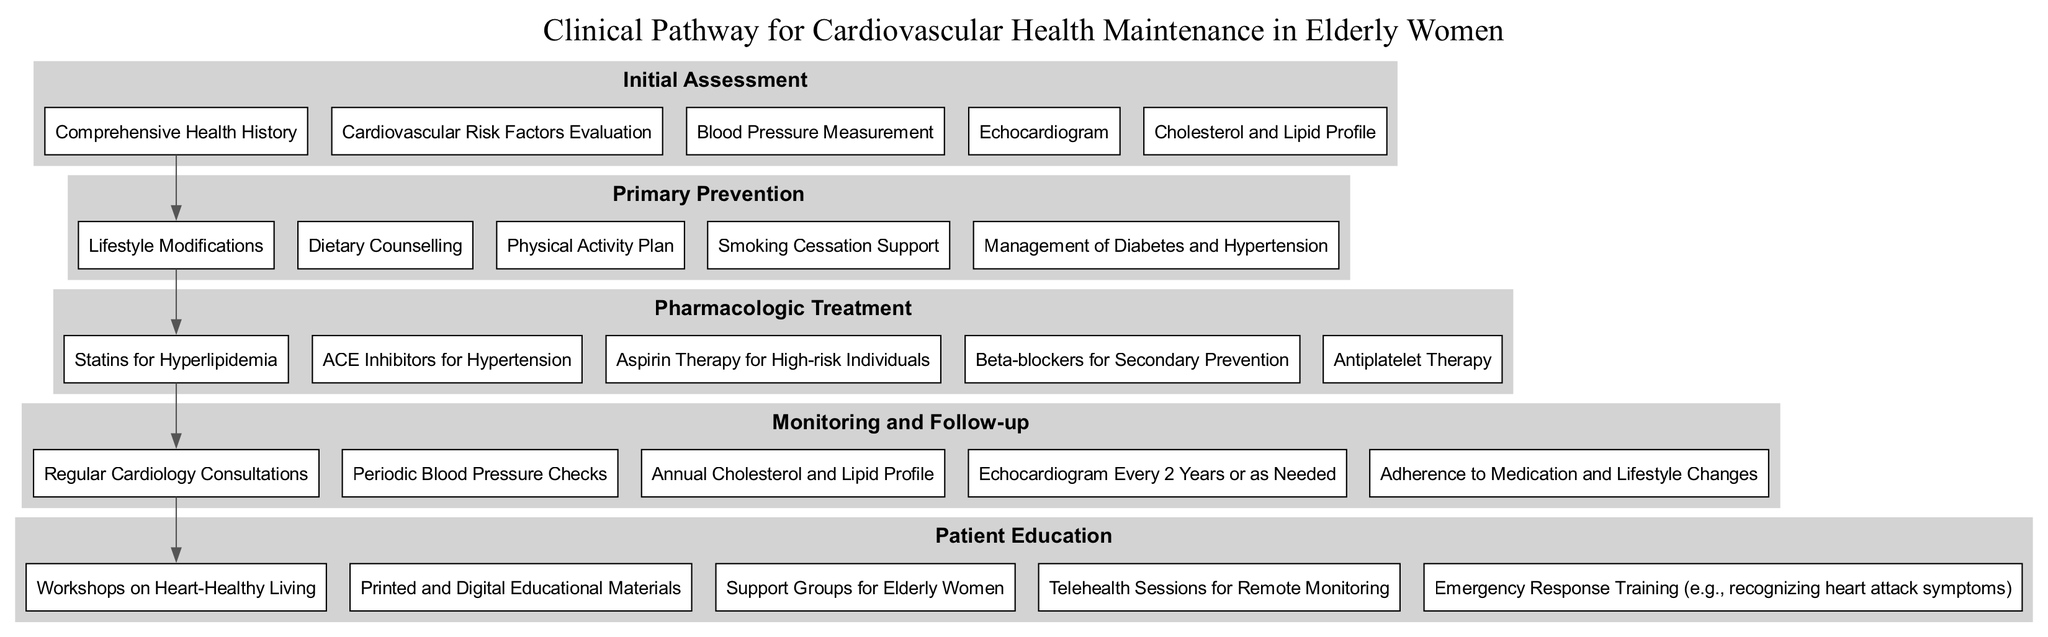What is the first stage in the Clinical Pathway? The first stage listed in the elements of the diagram is "Initial Assessment". It is presented at the top of the pathway, indicating the starting point for cardiovascular health maintenance.
Answer: Initial Assessment How many components are included in the Primary Prevention stage? The diagram indicates that there are five components listed under the Primary Prevention stage, reflecting various strategies to prevent cardiovascular issues.
Answer: 5 Which pharmacologic treatment is recommended for hypertension? The diagram specifically lists "ACE Inhibitors for Hypertension" as a component under the Pharmacologic Treatment stage. This indicates the targeted medication for that particular condition.
Answer: ACE Inhibitors What stage follows Monitoring and Follow-up? By examining the flow of the diagram, it is evident that Monitoring and Follow-up is the final stage, and thus, there is no subsequent stage.
Answer: None List two components from the Patient Education stage. The diagram shows that "Workshops on Heart-Healthy Living" and "Printed and Digital Educational Materials" are both included as components in the Patient Education stage.
Answer: Workshops on Heart-Healthy Living, Printed and Digital Educational Materials How are the stages connected in this Clinical Pathway? The diagram illustrates that the stages are connected in a linear fashion, each stage leading to the next, indicating sequential steps in cardiovascular health maintenance.
Answer: Linear connection What is the purpose of workshops included in Patient Education? The workshops aim to provide knowledge and skills about heart-healthy living, which is essential for elderly women in the context of cardiovascular health. This can be inferred from the components in the Patient Education stage.
Answer: Heart-healthy living Which component indicates support for smoking cessation? The pathway includes "Smoking Cessation Support" within the Primary Prevention stage, highlighting its importance in reducing cardiovascular risk factors among elderly women.
Answer: Smoking Cessation Support How often should cholesterol and lipid profiles be checked according to the Monitoring and Follow-up stage? The diagram specifies that cholesterol and lipid profiles should be evaluated annually, ensuring ongoing assessment of cardiovascular health in elderly women.
Answer: Annual 